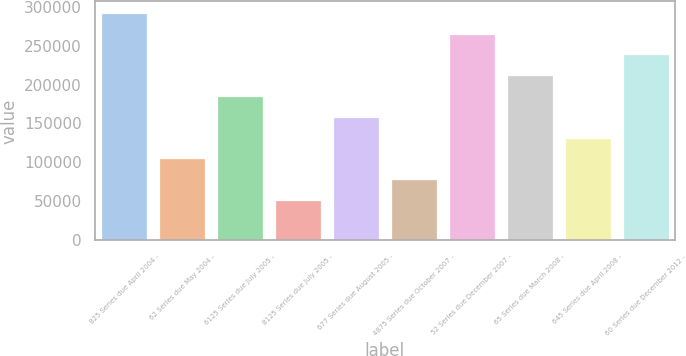Convert chart. <chart><loc_0><loc_0><loc_500><loc_500><bar_chart><fcel>825 Series due April 2004 -<fcel>62 Series due May 2004 -<fcel>6125 Series due July 2005 -<fcel>8125 Series due July 2005 -<fcel>677 Series due August 2005 -<fcel>4875 Series due October 2007 -<fcel>52 Series due December 2007 -<fcel>65 Series due March 2008 -<fcel>645 Series due April 2008 -<fcel>60 Series due December 2012 -<nl><fcel>292000<fcel>105100<fcel>185200<fcel>51700<fcel>158500<fcel>78400<fcel>265300<fcel>211900<fcel>131800<fcel>238600<nl></chart> 